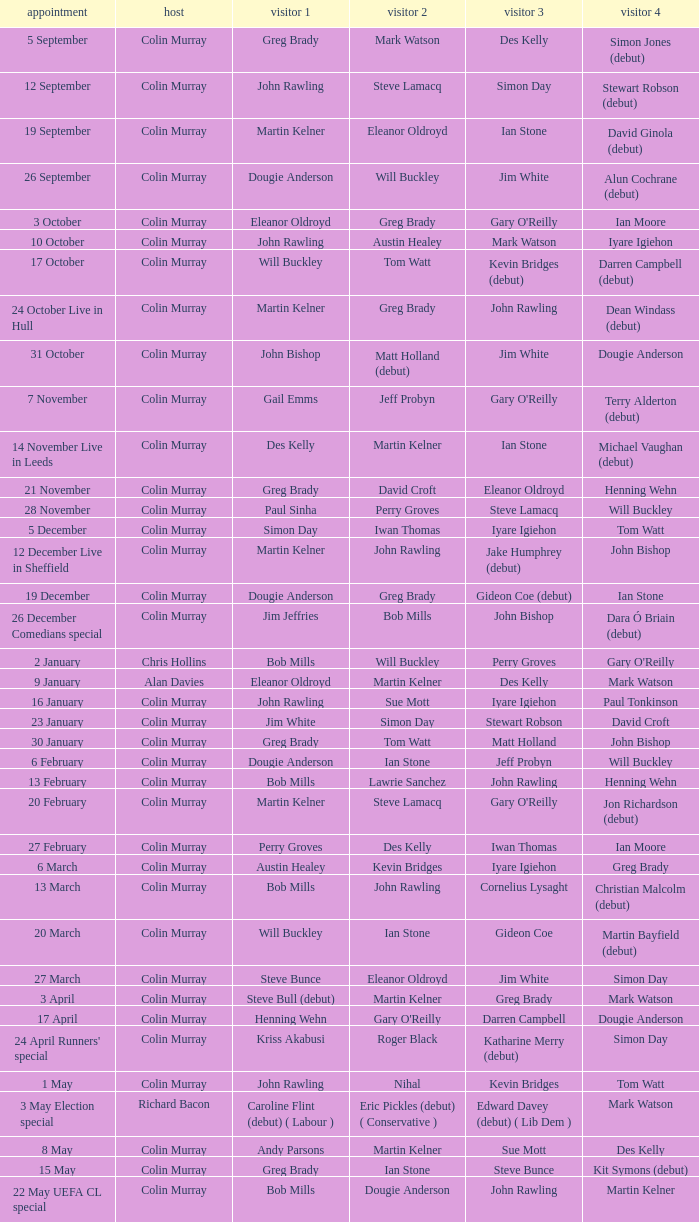How many people are guest 1 on episodes where guest 4 is Des Kelly? 1.0. 